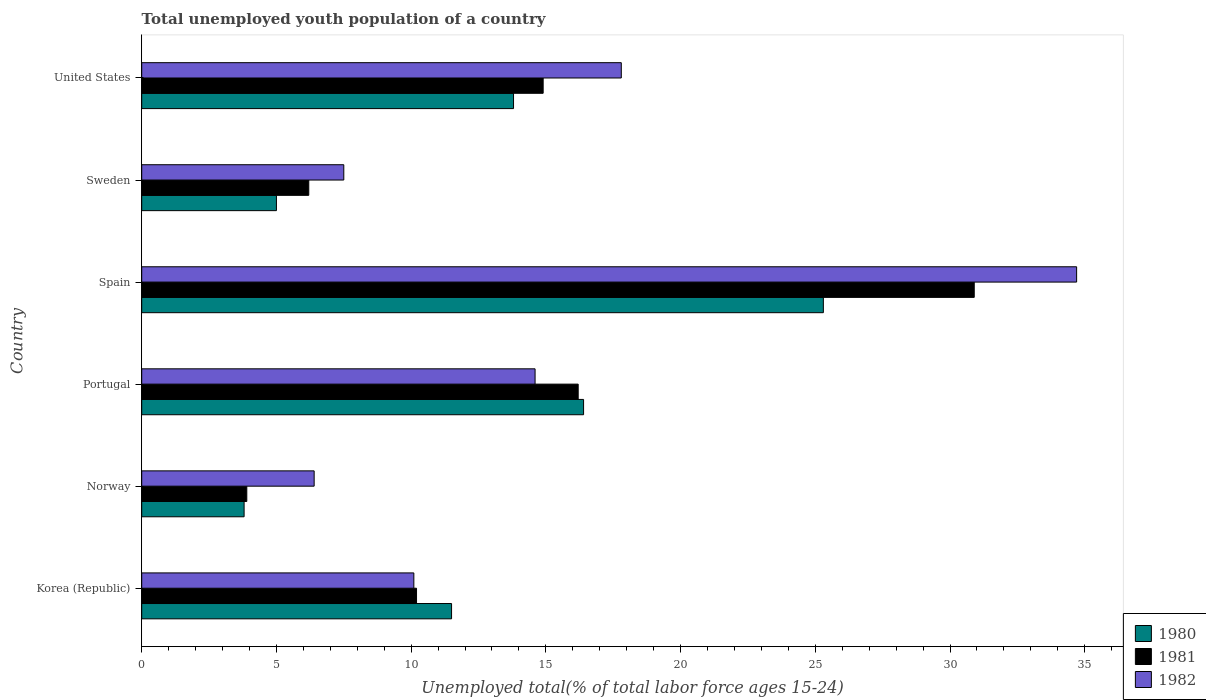How many different coloured bars are there?
Keep it short and to the point. 3. Are the number of bars per tick equal to the number of legend labels?
Make the answer very short. Yes. Are the number of bars on each tick of the Y-axis equal?
Ensure brevity in your answer.  Yes. How many bars are there on the 2nd tick from the top?
Provide a succinct answer. 3. How many bars are there on the 2nd tick from the bottom?
Provide a short and direct response. 3. In how many cases, is the number of bars for a given country not equal to the number of legend labels?
Your answer should be compact. 0. What is the percentage of total unemployed youth population of a country in 1981 in Norway?
Offer a very short reply. 3.9. Across all countries, what is the maximum percentage of total unemployed youth population of a country in 1981?
Your answer should be very brief. 30.9. Across all countries, what is the minimum percentage of total unemployed youth population of a country in 1981?
Ensure brevity in your answer.  3.9. In which country was the percentage of total unemployed youth population of a country in 1982 minimum?
Your answer should be compact. Norway. What is the total percentage of total unemployed youth population of a country in 1982 in the graph?
Provide a short and direct response. 91.1. What is the difference between the percentage of total unemployed youth population of a country in 1981 in Norway and that in Portugal?
Keep it short and to the point. -12.3. What is the difference between the percentage of total unemployed youth population of a country in 1980 in Spain and the percentage of total unemployed youth population of a country in 1982 in Sweden?
Offer a terse response. 17.8. What is the average percentage of total unemployed youth population of a country in 1980 per country?
Provide a succinct answer. 12.63. What is the difference between the percentage of total unemployed youth population of a country in 1980 and percentage of total unemployed youth population of a country in 1982 in Korea (Republic)?
Your answer should be compact. 1.4. In how many countries, is the percentage of total unemployed youth population of a country in 1982 greater than 8 %?
Your response must be concise. 4. What is the ratio of the percentage of total unemployed youth population of a country in 1980 in Korea (Republic) to that in Spain?
Provide a short and direct response. 0.45. Is the difference between the percentage of total unemployed youth population of a country in 1980 in Norway and Sweden greater than the difference between the percentage of total unemployed youth population of a country in 1982 in Norway and Sweden?
Provide a succinct answer. No. What is the difference between the highest and the second highest percentage of total unemployed youth population of a country in 1980?
Give a very brief answer. 8.9. What is the difference between the highest and the lowest percentage of total unemployed youth population of a country in 1981?
Provide a short and direct response. 27. In how many countries, is the percentage of total unemployed youth population of a country in 1980 greater than the average percentage of total unemployed youth population of a country in 1980 taken over all countries?
Make the answer very short. 3. What does the 1st bar from the bottom in United States represents?
Offer a terse response. 1980. How many bars are there?
Provide a succinct answer. 18. Are all the bars in the graph horizontal?
Offer a very short reply. Yes. What is the difference between two consecutive major ticks on the X-axis?
Your response must be concise. 5. Does the graph contain grids?
Provide a succinct answer. No. Where does the legend appear in the graph?
Provide a short and direct response. Bottom right. How many legend labels are there?
Ensure brevity in your answer.  3. How are the legend labels stacked?
Offer a very short reply. Vertical. What is the title of the graph?
Offer a very short reply. Total unemployed youth population of a country. Does "1980" appear as one of the legend labels in the graph?
Your answer should be compact. Yes. What is the label or title of the X-axis?
Offer a terse response. Unemployed total(% of total labor force ages 15-24). What is the label or title of the Y-axis?
Ensure brevity in your answer.  Country. What is the Unemployed total(% of total labor force ages 15-24) of 1981 in Korea (Republic)?
Provide a short and direct response. 10.2. What is the Unemployed total(% of total labor force ages 15-24) in 1982 in Korea (Republic)?
Offer a terse response. 10.1. What is the Unemployed total(% of total labor force ages 15-24) of 1980 in Norway?
Offer a terse response. 3.8. What is the Unemployed total(% of total labor force ages 15-24) of 1981 in Norway?
Your answer should be compact. 3.9. What is the Unemployed total(% of total labor force ages 15-24) of 1982 in Norway?
Your answer should be compact. 6.4. What is the Unemployed total(% of total labor force ages 15-24) of 1980 in Portugal?
Your answer should be compact. 16.4. What is the Unemployed total(% of total labor force ages 15-24) in 1981 in Portugal?
Offer a terse response. 16.2. What is the Unemployed total(% of total labor force ages 15-24) of 1982 in Portugal?
Offer a very short reply. 14.6. What is the Unemployed total(% of total labor force ages 15-24) of 1980 in Spain?
Offer a terse response. 25.3. What is the Unemployed total(% of total labor force ages 15-24) of 1981 in Spain?
Give a very brief answer. 30.9. What is the Unemployed total(% of total labor force ages 15-24) in 1982 in Spain?
Provide a succinct answer. 34.7. What is the Unemployed total(% of total labor force ages 15-24) of 1981 in Sweden?
Make the answer very short. 6.2. What is the Unemployed total(% of total labor force ages 15-24) in 1982 in Sweden?
Give a very brief answer. 7.5. What is the Unemployed total(% of total labor force ages 15-24) in 1980 in United States?
Offer a terse response. 13.8. What is the Unemployed total(% of total labor force ages 15-24) of 1981 in United States?
Keep it short and to the point. 14.9. What is the Unemployed total(% of total labor force ages 15-24) of 1982 in United States?
Keep it short and to the point. 17.8. Across all countries, what is the maximum Unemployed total(% of total labor force ages 15-24) of 1980?
Keep it short and to the point. 25.3. Across all countries, what is the maximum Unemployed total(% of total labor force ages 15-24) of 1981?
Offer a very short reply. 30.9. Across all countries, what is the maximum Unemployed total(% of total labor force ages 15-24) of 1982?
Make the answer very short. 34.7. Across all countries, what is the minimum Unemployed total(% of total labor force ages 15-24) in 1980?
Keep it short and to the point. 3.8. Across all countries, what is the minimum Unemployed total(% of total labor force ages 15-24) of 1981?
Provide a succinct answer. 3.9. Across all countries, what is the minimum Unemployed total(% of total labor force ages 15-24) of 1982?
Your response must be concise. 6.4. What is the total Unemployed total(% of total labor force ages 15-24) in 1980 in the graph?
Ensure brevity in your answer.  75.8. What is the total Unemployed total(% of total labor force ages 15-24) of 1981 in the graph?
Your answer should be very brief. 82.3. What is the total Unemployed total(% of total labor force ages 15-24) in 1982 in the graph?
Your response must be concise. 91.1. What is the difference between the Unemployed total(% of total labor force ages 15-24) of 1980 in Korea (Republic) and that in Norway?
Ensure brevity in your answer.  7.7. What is the difference between the Unemployed total(% of total labor force ages 15-24) in 1980 in Korea (Republic) and that in Portugal?
Give a very brief answer. -4.9. What is the difference between the Unemployed total(% of total labor force ages 15-24) in 1981 in Korea (Republic) and that in Portugal?
Your answer should be very brief. -6. What is the difference between the Unemployed total(% of total labor force ages 15-24) in 1982 in Korea (Republic) and that in Portugal?
Give a very brief answer. -4.5. What is the difference between the Unemployed total(% of total labor force ages 15-24) of 1980 in Korea (Republic) and that in Spain?
Ensure brevity in your answer.  -13.8. What is the difference between the Unemployed total(% of total labor force ages 15-24) in 1981 in Korea (Republic) and that in Spain?
Your response must be concise. -20.7. What is the difference between the Unemployed total(% of total labor force ages 15-24) of 1982 in Korea (Republic) and that in Spain?
Make the answer very short. -24.6. What is the difference between the Unemployed total(% of total labor force ages 15-24) in 1981 in Korea (Republic) and that in Sweden?
Your answer should be very brief. 4. What is the difference between the Unemployed total(% of total labor force ages 15-24) of 1982 in Korea (Republic) and that in Sweden?
Keep it short and to the point. 2.6. What is the difference between the Unemployed total(% of total labor force ages 15-24) of 1981 in Norway and that in Portugal?
Your answer should be compact. -12.3. What is the difference between the Unemployed total(% of total labor force ages 15-24) in 1982 in Norway and that in Portugal?
Keep it short and to the point. -8.2. What is the difference between the Unemployed total(% of total labor force ages 15-24) in 1980 in Norway and that in Spain?
Give a very brief answer. -21.5. What is the difference between the Unemployed total(% of total labor force ages 15-24) of 1981 in Norway and that in Spain?
Provide a short and direct response. -27. What is the difference between the Unemployed total(% of total labor force ages 15-24) in 1982 in Norway and that in Spain?
Your answer should be compact. -28.3. What is the difference between the Unemployed total(% of total labor force ages 15-24) of 1980 in Norway and that in Sweden?
Your response must be concise. -1.2. What is the difference between the Unemployed total(% of total labor force ages 15-24) of 1982 in Norway and that in Sweden?
Provide a succinct answer. -1.1. What is the difference between the Unemployed total(% of total labor force ages 15-24) in 1980 in Norway and that in United States?
Your answer should be very brief. -10. What is the difference between the Unemployed total(% of total labor force ages 15-24) of 1981 in Norway and that in United States?
Keep it short and to the point. -11. What is the difference between the Unemployed total(% of total labor force ages 15-24) of 1980 in Portugal and that in Spain?
Offer a terse response. -8.9. What is the difference between the Unemployed total(% of total labor force ages 15-24) of 1981 in Portugal and that in Spain?
Your answer should be very brief. -14.7. What is the difference between the Unemployed total(% of total labor force ages 15-24) of 1982 in Portugal and that in Spain?
Make the answer very short. -20.1. What is the difference between the Unemployed total(% of total labor force ages 15-24) in 1980 in Portugal and that in Sweden?
Offer a terse response. 11.4. What is the difference between the Unemployed total(% of total labor force ages 15-24) in 1981 in Portugal and that in Sweden?
Keep it short and to the point. 10. What is the difference between the Unemployed total(% of total labor force ages 15-24) in 1982 in Portugal and that in Sweden?
Provide a short and direct response. 7.1. What is the difference between the Unemployed total(% of total labor force ages 15-24) in 1981 in Portugal and that in United States?
Keep it short and to the point. 1.3. What is the difference between the Unemployed total(% of total labor force ages 15-24) in 1980 in Spain and that in Sweden?
Offer a terse response. 20.3. What is the difference between the Unemployed total(% of total labor force ages 15-24) of 1981 in Spain and that in Sweden?
Give a very brief answer. 24.7. What is the difference between the Unemployed total(% of total labor force ages 15-24) of 1982 in Spain and that in Sweden?
Keep it short and to the point. 27.2. What is the difference between the Unemployed total(% of total labor force ages 15-24) of 1981 in Spain and that in United States?
Your answer should be compact. 16. What is the difference between the Unemployed total(% of total labor force ages 15-24) of 1982 in Spain and that in United States?
Your answer should be compact. 16.9. What is the difference between the Unemployed total(% of total labor force ages 15-24) in 1980 in Sweden and that in United States?
Offer a terse response. -8.8. What is the difference between the Unemployed total(% of total labor force ages 15-24) in 1981 in Sweden and that in United States?
Offer a very short reply. -8.7. What is the difference between the Unemployed total(% of total labor force ages 15-24) of 1980 in Korea (Republic) and the Unemployed total(% of total labor force ages 15-24) of 1981 in Norway?
Offer a very short reply. 7.6. What is the difference between the Unemployed total(% of total labor force ages 15-24) of 1980 in Korea (Republic) and the Unemployed total(% of total labor force ages 15-24) of 1982 in Norway?
Ensure brevity in your answer.  5.1. What is the difference between the Unemployed total(% of total labor force ages 15-24) in 1981 in Korea (Republic) and the Unemployed total(% of total labor force ages 15-24) in 1982 in Norway?
Make the answer very short. 3.8. What is the difference between the Unemployed total(% of total labor force ages 15-24) in 1980 in Korea (Republic) and the Unemployed total(% of total labor force ages 15-24) in 1981 in Portugal?
Give a very brief answer. -4.7. What is the difference between the Unemployed total(% of total labor force ages 15-24) in 1980 in Korea (Republic) and the Unemployed total(% of total labor force ages 15-24) in 1982 in Portugal?
Give a very brief answer. -3.1. What is the difference between the Unemployed total(% of total labor force ages 15-24) in 1980 in Korea (Republic) and the Unemployed total(% of total labor force ages 15-24) in 1981 in Spain?
Offer a terse response. -19.4. What is the difference between the Unemployed total(% of total labor force ages 15-24) of 1980 in Korea (Republic) and the Unemployed total(% of total labor force ages 15-24) of 1982 in Spain?
Provide a succinct answer. -23.2. What is the difference between the Unemployed total(% of total labor force ages 15-24) in 1981 in Korea (Republic) and the Unemployed total(% of total labor force ages 15-24) in 1982 in Spain?
Your answer should be very brief. -24.5. What is the difference between the Unemployed total(% of total labor force ages 15-24) in 1980 in Korea (Republic) and the Unemployed total(% of total labor force ages 15-24) in 1981 in Sweden?
Your response must be concise. 5.3. What is the difference between the Unemployed total(% of total labor force ages 15-24) of 1981 in Korea (Republic) and the Unemployed total(% of total labor force ages 15-24) of 1982 in Sweden?
Keep it short and to the point. 2.7. What is the difference between the Unemployed total(% of total labor force ages 15-24) of 1980 in Korea (Republic) and the Unemployed total(% of total labor force ages 15-24) of 1981 in United States?
Your response must be concise. -3.4. What is the difference between the Unemployed total(% of total labor force ages 15-24) in 1980 in Korea (Republic) and the Unemployed total(% of total labor force ages 15-24) in 1982 in United States?
Make the answer very short. -6.3. What is the difference between the Unemployed total(% of total labor force ages 15-24) in 1981 in Korea (Republic) and the Unemployed total(% of total labor force ages 15-24) in 1982 in United States?
Your answer should be very brief. -7.6. What is the difference between the Unemployed total(% of total labor force ages 15-24) in 1980 in Norway and the Unemployed total(% of total labor force ages 15-24) in 1981 in Portugal?
Your answer should be compact. -12.4. What is the difference between the Unemployed total(% of total labor force ages 15-24) in 1980 in Norway and the Unemployed total(% of total labor force ages 15-24) in 1982 in Portugal?
Ensure brevity in your answer.  -10.8. What is the difference between the Unemployed total(% of total labor force ages 15-24) in 1980 in Norway and the Unemployed total(% of total labor force ages 15-24) in 1981 in Spain?
Ensure brevity in your answer.  -27.1. What is the difference between the Unemployed total(% of total labor force ages 15-24) in 1980 in Norway and the Unemployed total(% of total labor force ages 15-24) in 1982 in Spain?
Your response must be concise. -30.9. What is the difference between the Unemployed total(% of total labor force ages 15-24) in 1981 in Norway and the Unemployed total(% of total labor force ages 15-24) in 1982 in Spain?
Your response must be concise. -30.8. What is the difference between the Unemployed total(% of total labor force ages 15-24) in 1980 in Norway and the Unemployed total(% of total labor force ages 15-24) in 1982 in Sweden?
Your answer should be very brief. -3.7. What is the difference between the Unemployed total(% of total labor force ages 15-24) of 1980 in Norway and the Unemployed total(% of total labor force ages 15-24) of 1981 in United States?
Your answer should be very brief. -11.1. What is the difference between the Unemployed total(% of total labor force ages 15-24) of 1980 in Portugal and the Unemployed total(% of total labor force ages 15-24) of 1982 in Spain?
Your answer should be compact. -18.3. What is the difference between the Unemployed total(% of total labor force ages 15-24) of 1981 in Portugal and the Unemployed total(% of total labor force ages 15-24) of 1982 in Spain?
Your answer should be compact. -18.5. What is the difference between the Unemployed total(% of total labor force ages 15-24) in 1981 in Portugal and the Unemployed total(% of total labor force ages 15-24) in 1982 in Sweden?
Give a very brief answer. 8.7. What is the difference between the Unemployed total(% of total labor force ages 15-24) of 1981 in Portugal and the Unemployed total(% of total labor force ages 15-24) of 1982 in United States?
Your response must be concise. -1.6. What is the difference between the Unemployed total(% of total labor force ages 15-24) in 1980 in Spain and the Unemployed total(% of total labor force ages 15-24) in 1982 in Sweden?
Your answer should be very brief. 17.8. What is the difference between the Unemployed total(% of total labor force ages 15-24) of 1981 in Spain and the Unemployed total(% of total labor force ages 15-24) of 1982 in Sweden?
Your response must be concise. 23.4. What is the difference between the Unemployed total(% of total labor force ages 15-24) of 1980 in Spain and the Unemployed total(% of total labor force ages 15-24) of 1981 in United States?
Keep it short and to the point. 10.4. What is the difference between the Unemployed total(% of total labor force ages 15-24) of 1980 in Spain and the Unemployed total(% of total labor force ages 15-24) of 1982 in United States?
Provide a succinct answer. 7.5. What is the difference between the Unemployed total(% of total labor force ages 15-24) in 1981 in Spain and the Unemployed total(% of total labor force ages 15-24) in 1982 in United States?
Give a very brief answer. 13.1. What is the difference between the Unemployed total(% of total labor force ages 15-24) in 1980 in Sweden and the Unemployed total(% of total labor force ages 15-24) in 1982 in United States?
Your answer should be very brief. -12.8. What is the average Unemployed total(% of total labor force ages 15-24) of 1980 per country?
Your answer should be very brief. 12.63. What is the average Unemployed total(% of total labor force ages 15-24) of 1981 per country?
Ensure brevity in your answer.  13.72. What is the average Unemployed total(% of total labor force ages 15-24) in 1982 per country?
Offer a very short reply. 15.18. What is the difference between the Unemployed total(% of total labor force ages 15-24) in 1980 and Unemployed total(% of total labor force ages 15-24) in 1981 in Korea (Republic)?
Provide a succinct answer. 1.3. What is the difference between the Unemployed total(% of total labor force ages 15-24) of 1980 and Unemployed total(% of total labor force ages 15-24) of 1982 in Korea (Republic)?
Your answer should be compact. 1.4. What is the difference between the Unemployed total(% of total labor force ages 15-24) in 1981 and Unemployed total(% of total labor force ages 15-24) in 1982 in Korea (Republic)?
Make the answer very short. 0.1. What is the difference between the Unemployed total(% of total labor force ages 15-24) in 1980 and Unemployed total(% of total labor force ages 15-24) in 1982 in Norway?
Provide a short and direct response. -2.6. What is the difference between the Unemployed total(% of total labor force ages 15-24) in 1980 and Unemployed total(% of total labor force ages 15-24) in 1981 in Portugal?
Make the answer very short. 0.2. What is the difference between the Unemployed total(% of total labor force ages 15-24) of 1980 and Unemployed total(% of total labor force ages 15-24) of 1982 in Portugal?
Offer a very short reply. 1.8. What is the difference between the Unemployed total(% of total labor force ages 15-24) in 1981 and Unemployed total(% of total labor force ages 15-24) in 1982 in Portugal?
Ensure brevity in your answer.  1.6. What is the difference between the Unemployed total(% of total labor force ages 15-24) of 1980 and Unemployed total(% of total labor force ages 15-24) of 1982 in Spain?
Ensure brevity in your answer.  -9.4. What is the difference between the Unemployed total(% of total labor force ages 15-24) in 1980 and Unemployed total(% of total labor force ages 15-24) in 1981 in Sweden?
Your answer should be very brief. -1.2. What is the difference between the Unemployed total(% of total labor force ages 15-24) of 1980 and Unemployed total(% of total labor force ages 15-24) of 1982 in Sweden?
Your answer should be very brief. -2.5. What is the difference between the Unemployed total(% of total labor force ages 15-24) of 1981 and Unemployed total(% of total labor force ages 15-24) of 1982 in Sweden?
Offer a terse response. -1.3. What is the ratio of the Unemployed total(% of total labor force ages 15-24) in 1980 in Korea (Republic) to that in Norway?
Provide a short and direct response. 3.03. What is the ratio of the Unemployed total(% of total labor force ages 15-24) in 1981 in Korea (Republic) to that in Norway?
Ensure brevity in your answer.  2.62. What is the ratio of the Unemployed total(% of total labor force ages 15-24) of 1982 in Korea (Republic) to that in Norway?
Keep it short and to the point. 1.58. What is the ratio of the Unemployed total(% of total labor force ages 15-24) of 1980 in Korea (Republic) to that in Portugal?
Provide a succinct answer. 0.7. What is the ratio of the Unemployed total(% of total labor force ages 15-24) in 1981 in Korea (Republic) to that in Portugal?
Offer a very short reply. 0.63. What is the ratio of the Unemployed total(% of total labor force ages 15-24) of 1982 in Korea (Republic) to that in Portugal?
Your answer should be very brief. 0.69. What is the ratio of the Unemployed total(% of total labor force ages 15-24) of 1980 in Korea (Republic) to that in Spain?
Provide a succinct answer. 0.45. What is the ratio of the Unemployed total(% of total labor force ages 15-24) in 1981 in Korea (Republic) to that in Spain?
Give a very brief answer. 0.33. What is the ratio of the Unemployed total(% of total labor force ages 15-24) of 1982 in Korea (Republic) to that in Spain?
Keep it short and to the point. 0.29. What is the ratio of the Unemployed total(% of total labor force ages 15-24) of 1980 in Korea (Republic) to that in Sweden?
Offer a very short reply. 2.3. What is the ratio of the Unemployed total(% of total labor force ages 15-24) in 1981 in Korea (Republic) to that in Sweden?
Your answer should be compact. 1.65. What is the ratio of the Unemployed total(% of total labor force ages 15-24) in 1982 in Korea (Republic) to that in Sweden?
Provide a short and direct response. 1.35. What is the ratio of the Unemployed total(% of total labor force ages 15-24) in 1980 in Korea (Republic) to that in United States?
Offer a terse response. 0.83. What is the ratio of the Unemployed total(% of total labor force ages 15-24) in 1981 in Korea (Republic) to that in United States?
Provide a succinct answer. 0.68. What is the ratio of the Unemployed total(% of total labor force ages 15-24) in 1982 in Korea (Republic) to that in United States?
Give a very brief answer. 0.57. What is the ratio of the Unemployed total(% of total labor force ages 15-24) in 1980 in Norway to that in Portugal?
Keep it short and to the point. 0.23. What is the ratio of the Unemployed total(% of total labor force ages 15-24) of 1981 in Norway to that in Portugal?
Provide a succinct answer. 0.24. What is the ratio of the Unemployed total(% of total labor force ages 15-24) of 1982 in Norway to that in Portugal?
Your response must be concise. 0.44. What is the ratio of the Unemployed total(% of total labor force ages 15-24) in 1980 in Norway to that in Spain?
Ensure brevity in your answer.  0.15. What is the ratio of the Unemployed total(% of total labor force ages 15-24) in 1981 in Norway to that in Spain?
Offer a very short reply. 0.13. What is the ratio of the Unemployed total(% of total labor force ages 15-24) in 1982 in Norway to that in Spain?
Give a very brief answer. 0.18. What is the ratio of the Unemployed total(% of total labor force ages 15-24) of 1980 in Norway to that in Sweden?
Give a very brief answer. 0.76. What is the ratio of the Unemployed total(% of total labor force ages 15-24) of 1981 in Norway to that in Sweden?
Make the answer very short. 0.63. What is the ratio of the Unemployed total(% of total labor force ages 15-24) of 1982 in Norway to that in Sweden?
Ensure brevity in your answer.  0.85. What is the ratio of the Unemployed total(% of total labor force ages 15-24) of 1980 in Norway to that in United States?
Provide a succinct answer. 0.28. What is the ratio of the Unemployed total(% of total labor force ages 15-24) of 1981 in Norway to that in United States?
Keep it short and to the point. 0.26. What is the ratio of the Unemployed total(% of total labor force ages 15-24) in 1982 in Norway to that in United States?
Keep it short and to the point. 0.36. What is the ratio of the Unemployed total(% of total labor force ages 15-24) of 1980 in Portugal to that in Spain?
Make the answer very short. 0.65. What is the ratio of the Unemployed total(% of total labor force ages 15-24) of 1981 in Portugal to that in Spain?
Provide a succinct answer. 0.52. What is the ratio of the Unemployed total(% of total labor force ages 15-24) of 1982 in Portugal to that in Spain?
Your answer should be very brief. 0.42. What is the ratio of the Unemployed total(% of total labor force ages 15-24) of 1980 in Portugal to that in Sweden?
Offer a terse response. 3.28. What is the ratio of the Unemployed total(% of total labor force ages 15-24) in 1981 in Portugal to that in Sweden?
Offer a terse response. 2.61. What is the ratio of the Unemployed total(% of total labor force ages 15-24) of 1982 in Portugal to that in Sweden?
Offer a terse response. 1.95. What is the ratio of the Unemployed total(% of total labor force ages 15-24) in 1980 in Portugal to that in United States?
Offer a terse response. 1.19. What is the ratio of the Unemployed total(% of total labor force ages 15-24) in 1981 in Portugal to that in United States?
Offer a terse response. 1.09. What is the ratio of the Unemployed total(% of total labor force ages 15-24) in 1982 in Portugal to that in United States?
Provide a succinct answer. 0.82. What is the ratio of the Unemployed total(% of total labor force ages 15-24) of 1980 in Spain to that in Sweden?
Give a very brief answer. 5.06. What is the ratio of the Unemployed total(% of total labor force ages 15-24) of 1981 in Spain to that in Sweden?
Your answer should be compact. 4.98. What is the ratio of the Unemployed total(% of total labor force ages 15-24) of 1982 in Spain to that in Sweden?
Offer a terse response. 4.63. What is the ratio of the Unemployed total(% of total labor force ages 15-24) of 1980 in Spain to that in United States?
Keep it short and to the point. 1.83. What is the ratio of the Unemployed total(% of total labor force ages 15-24) in 1981 in Spain to that in United States?
Provide a short and direct response. 2.07. What is the ratio of the Unemployed total(% of total labor force ages 15-24) in 1982 in Spain to that in United States?
Your answer should be very brief. 1.95. What is the ratio of the Unemployed total(% of total labor force ages 15-24) of 1980 in Sweden to that in United States?
Your answer should be compact. 0.36. What is the ratio of the Unemployed total(% of total labor force ages 15-24) of 1981 in Sweden to that in United States?
Give a very brief answer. 0.42. What is the ratio of the Unemployed total(% of total labor force ages 15-24) in 1982 in Sweden to that in United States?
Your answer should be compact. 0.42. What is the difference between the highest and the second highest Unemployed total(% of total labor force ages 15-24) in 1980?
Your answer should be compact. 8.9. What is the difference between the highest and the second highest Unemployed total(% of total labor force ages 15-24) in 1982?
Your answer should be very brief. 16.9. What is the difference between the highest and the lowest Unemployed total(% of total labor force ages 15-24) in 1980?
Ensure brevity in your answer.  21.5. What is the difference between the highest and the lowest Unemployed total(% of total labor force ages 15-24) in 1982?
Ensure brevity in your answer.  28.3. 